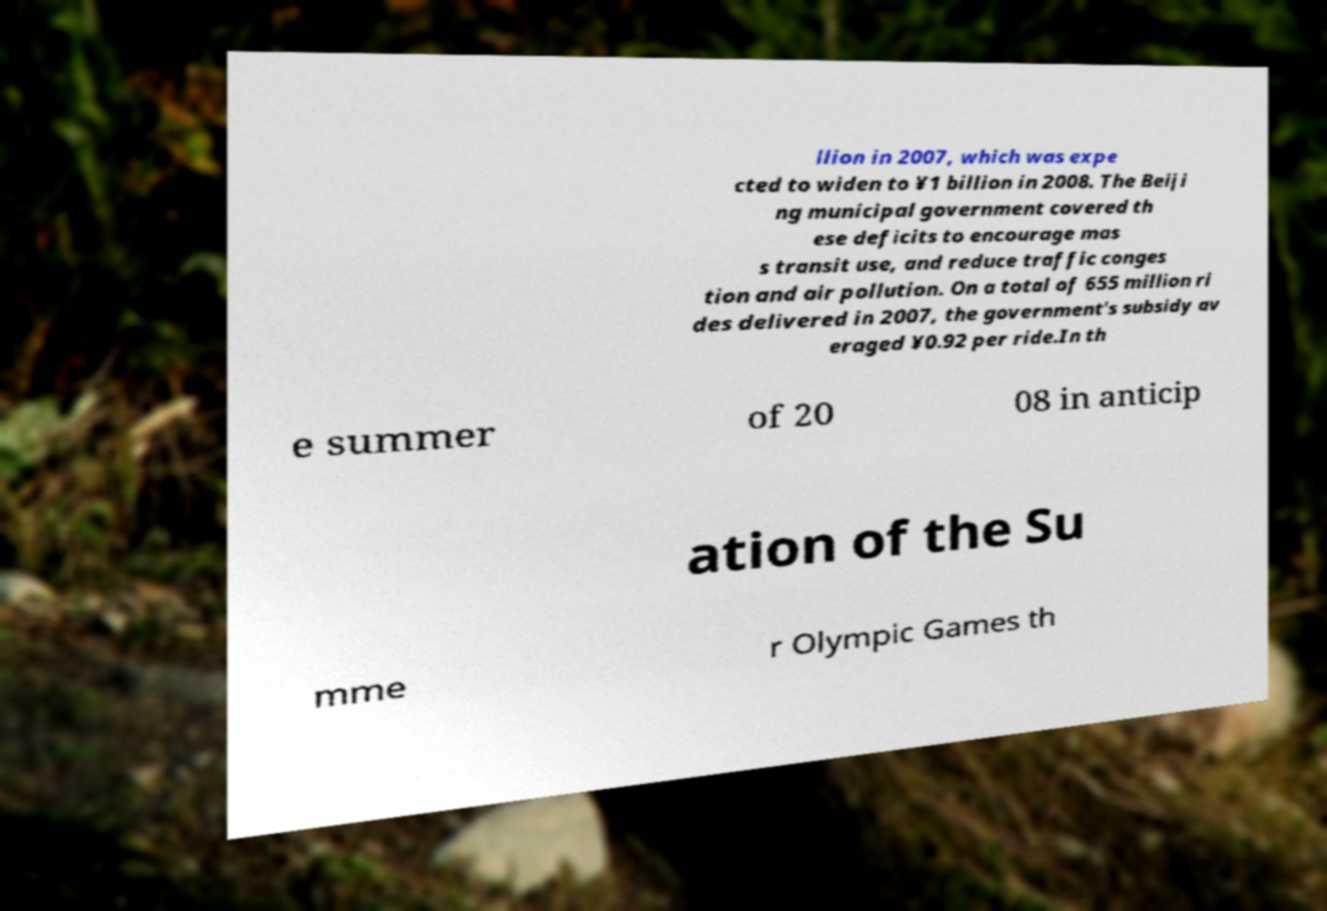Can you accurately transcribe the text from the provided image for me? llion in 2007, which was expe cted to widen to ¥1 billion in 2008. The Beiji ng municipal government covered th ese deficits to encourage mas s transit use, and reduce traffic conges tion and air pollution. On a total of 655 million ri des delivered in 2007, the government's subsidy av eraged ¥0.92 per ride.In th e summer of 20 08 in anticip ation of the Su mme r Olympic Games th 